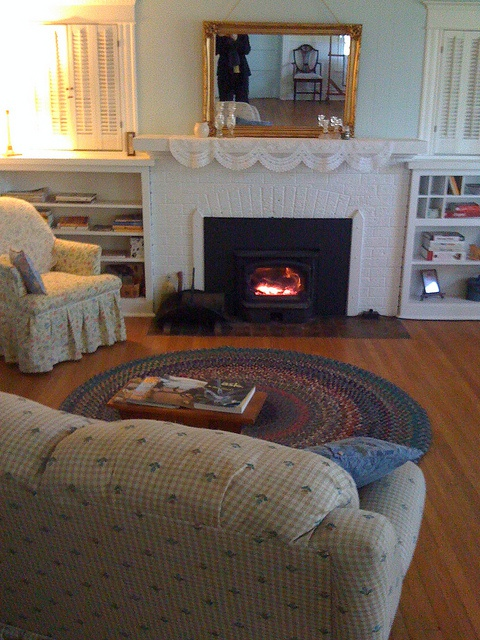Describe the objects in this image and their specific colors. I can see couch in white, black, and gray tones, chair in white and gray tones, book in white, gray, maroon, and black tones, people in white, black, gray, and navy tones, and chair in white, gray, black, and navy tones in this image. 